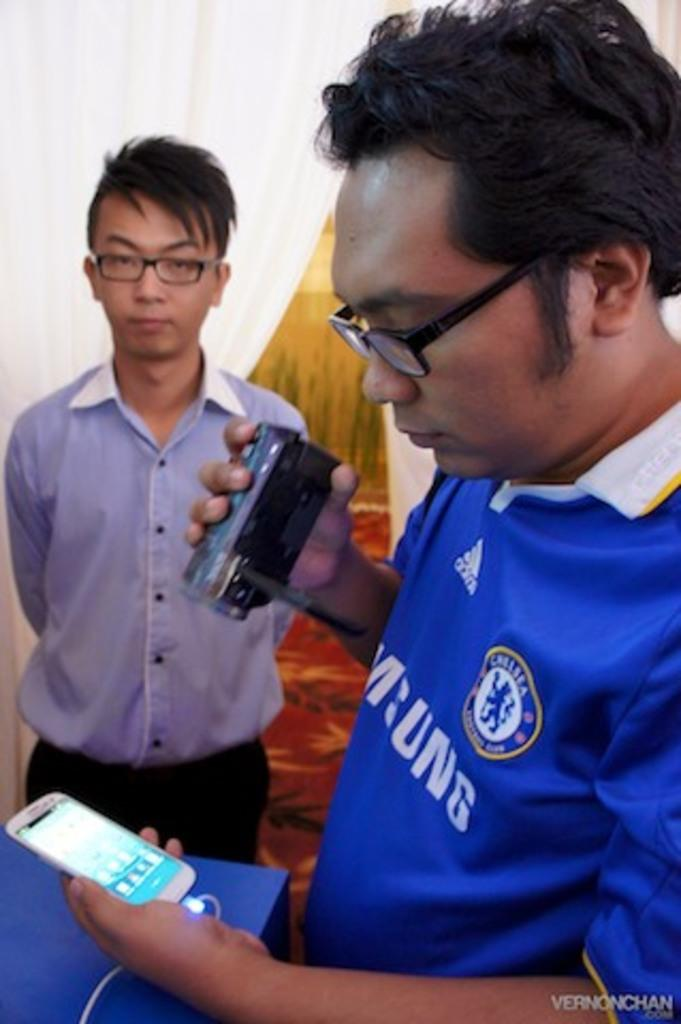What is the man in the image doing with his hands? The man is holding a camera and a mobile in his hands. Can you describe the other man in the image? There is another man standing on the side in the image. What might the man with the camera be doing? The man with the camera might be taking a picture or recording a video. What grade is the crowd in the image protesting against? There is no crowd or protest present in the image; it only features two men. 